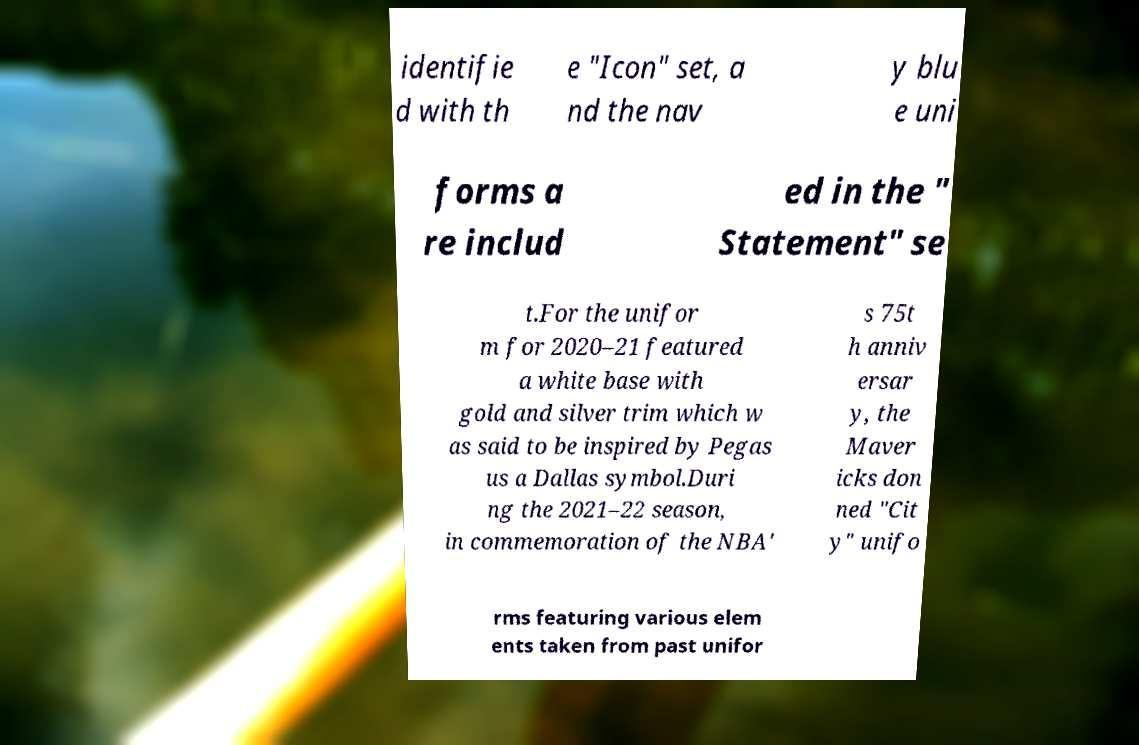Can you read and provide the text displayed in the image?This photo seems to have some interesting text. Can you extract and type it out for me? identifie d with th e "Icon" set, a nd the nav y blu e uni forms a re includ ed in the " Statement" se t.For the unifor m for 2020–21 featured a white base with gold and silver trim which w as said to be inspired by Pegas us a Dallas symbol.Duri ng the 2021–22 season, in commemoration of the NBA' s 75t h anniv ersar y, the Maver icks don ned "Cit y" unifo rms featuring various elem ents taken from past unifor 